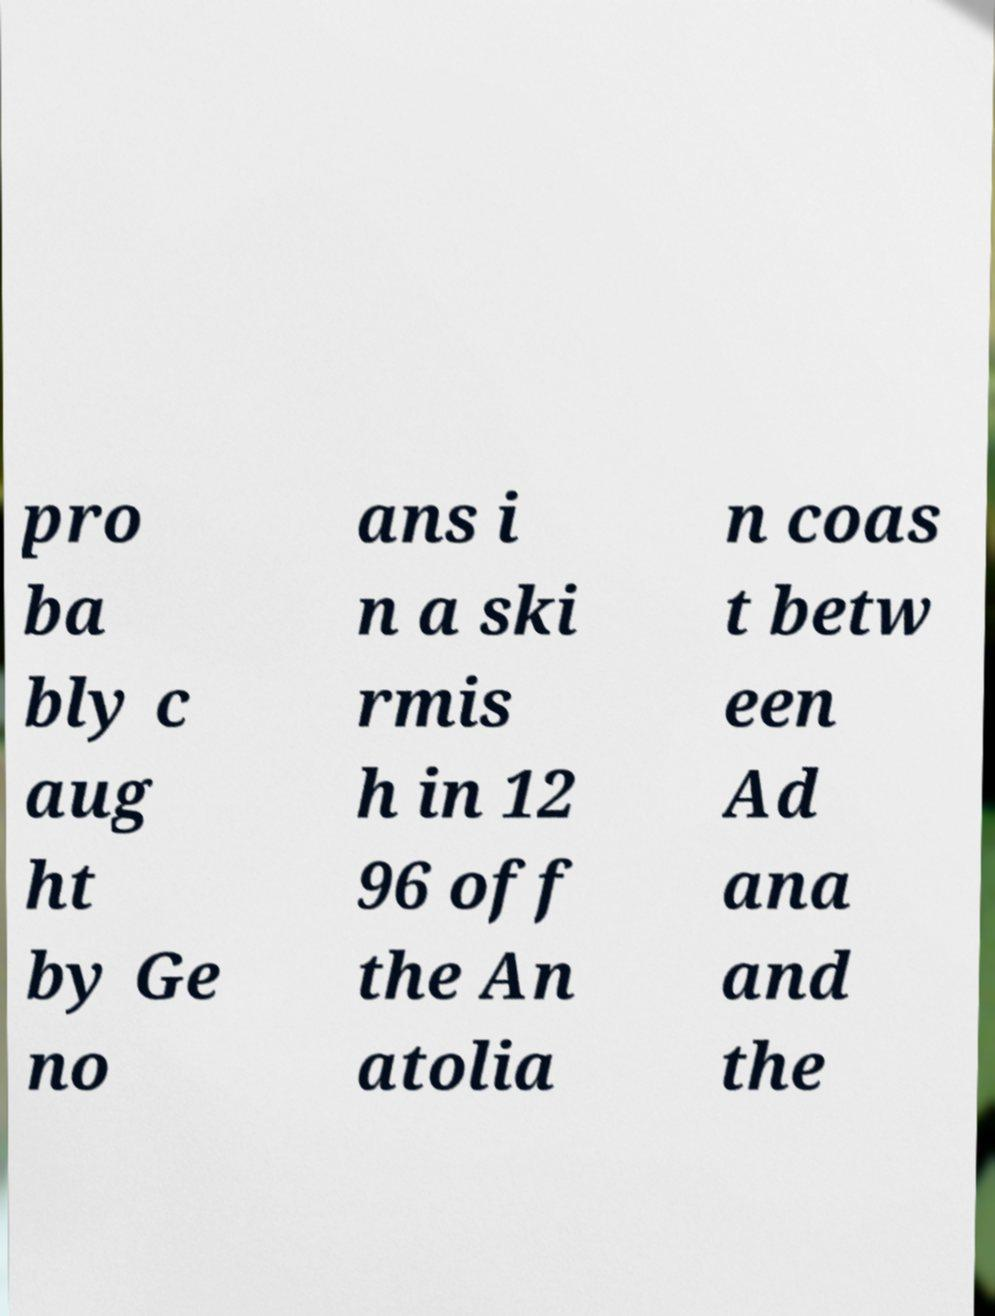I need the written content from this picture converted into text. Can you do that? pro ba bly c aug ht by Ge no ans i n a ski rmis h in 12 96 off the An atolia n coas t betw een Ad ana and the 